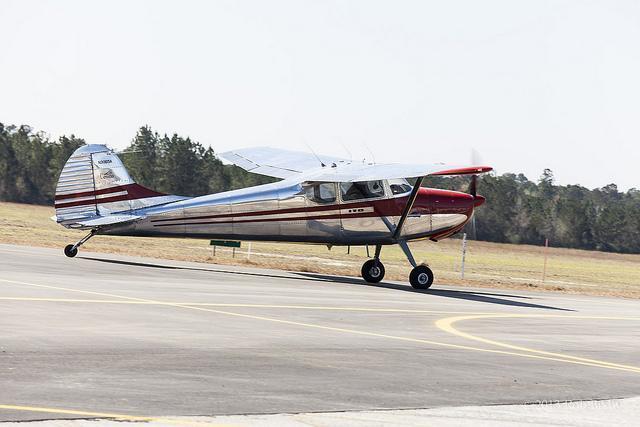How many wheels on the plane?
Give a very brief answer. 3. How many parts are red?
Give a very brief answer. 3. How many men are in this picture?
Give a very brief answer. 0. 